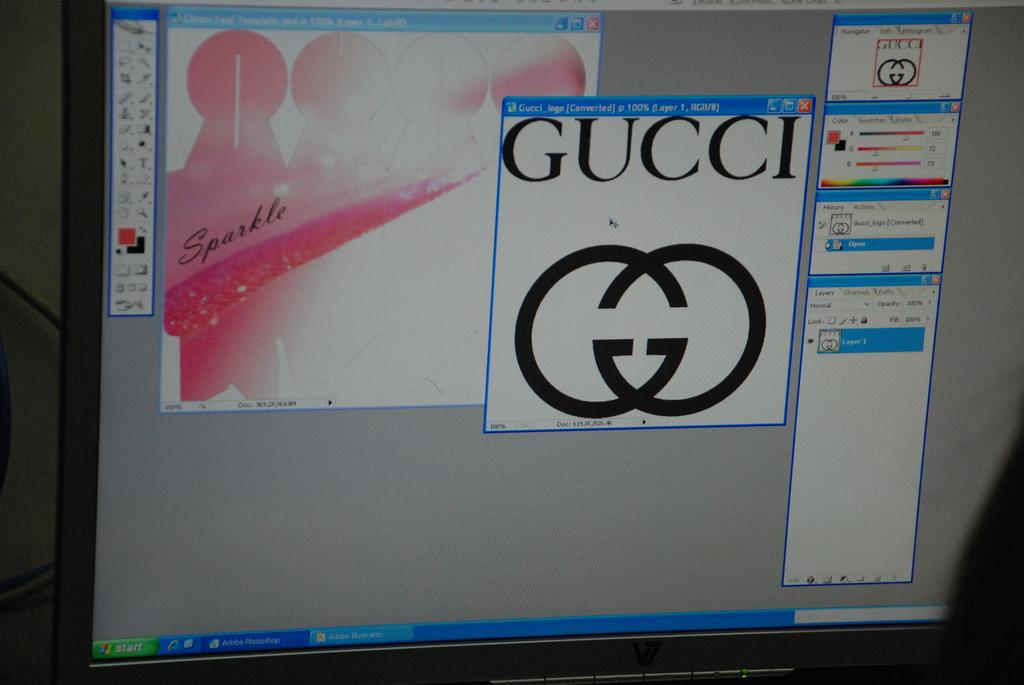<image>
Create a compact narrative representing the image presented. A computer screen shows the compnents of a Gucci advert in an image editor. 